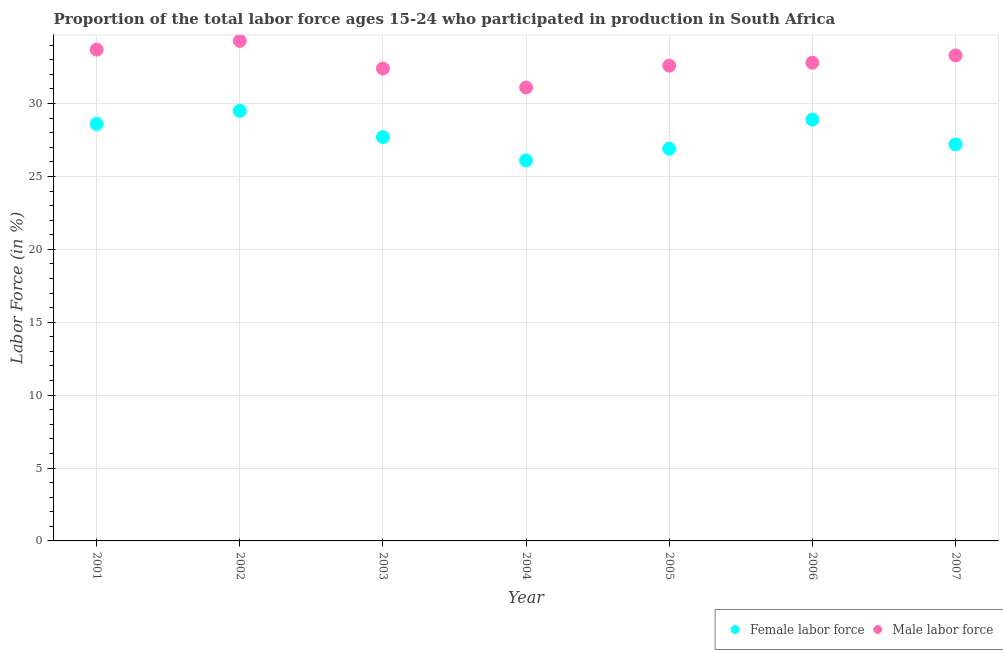How many different coloured dotlines are there?
Give a very brief answer. 2. Is the number of dotlines equal to the number of legend labels?
Offer a terse response. Yes. What is the percentage of male labour force in 2005?
Make the answer very short. 32.6. Across all years, what is the maximum percentage of male labour force?
Keep it short and to the point. 34.3. Across all years, what is the minimum percentage of male labour force?
Your answer should be compact. 31.1. What is the total percentage of male labour force in the graph?
Offer a terse response. 230.2. What is the difference between the percentage of male labour force in 2004 and that in 2006?
Offer a very short reply. -1.7. What is the difference between the percentage of female labor force in 2006 and the percentage of male labour force in 2004?
Offer a very short reply. -2.2. What is the average percentage of male labour force per year?
Your answer should be compact. 32.89. In the year 2001, what is the difference between the percentage of female labor force and percentage of male labour force?
Provide a succinct answer. -5.1. What is the ratio of the percentage of female labor force in 2002 to that in 2006?
Keep it short and to the point. 1.02. What is the difference between the highest and the second highest percentage of female labor force?
Provide a succinct answer. 0.6. What is the difference between the highest and the lowest percentage of male labour force?
Provide a short and direct response. 3.2. In how many years, is the percentage of male labour force greater than the average percentage of male labour force taken over all years?
Ensure brevity in your answer.  3. Is the sum of the percentage of male labour force in 2003 and 2004 greater than the maximum percentage of female labor force across all years?
Make the answer very short. Yes. Does the percentage of female labor force monotonically increase over the years?
Ensure brevity in your answer.  No. Is the percentage of male labour force strictly less than the percentage of female labor force over the years?
Make the answer very short. No. How many dotlines are there?
Make the answer very short. 2. How many years are there in the graph?
Keep it short and to the point. 7. What is the difference between two consecutive major ticks on the Y-axis?
Your answer should be very brief. 5. Does the graph contain grids?
Offer a terse response. Yes. Where does the legend appear in the graph?
Your answer should be compact. Bottom right. What is the title of the graph?
Your answer should be compact. Proportion of the total labor force ages 15-24 who participated in production in South Africa. What is the label or title of the X-axis?
Give a very brief answer. Year. What is the Labor Force (in %) in Female labor force in 2001?
Keep it short and to the point. 28.6. What is the Labor Force (in %) of Male labor force in 2001?
Offer a very short reply. 33.7. What is the Labor Force (in %) in Female labor force in 2002?
Ensure brevity in your answer.  29.5. What is the Labor Force (in %) of Male labor force in 2002?
Ensure brevity in your answer.  34.3. What is the Labor Force (in %) of Female labor force in 2003?
Provide a succinct answer. 27.7. What is the Labor Force (in %) of Male labor force in 2003?
Offer a terse response. 32.4. What is the Labor Force (in %) of Female labor force in 2004?
Your answer should be very brief. 26.1. What is the Labor Force (in %) of Male labor force in 2004?
Your answer should be compact. 31.1. What is the Labor Force (in %) of Female labor force in 2005?
Offer a very short reply. 26.9. What is the Labor Force (in %) in Male labor force in 2005?
Ensure brevity in your answer.  32.6. What is the Labor Force (in %) of Female labor force in 2006?
Offer a very short reply. 28.9. What is the Labor Force (in %) of Male labor force in 2006?
Your answer should be compact. 32.8. What is the Labor Force (in %) of Female labor force in 2007?
Make the answer very short. 27.2. What is the Labor Force (in %) in Male labor force in 2007?
Offer a very short reply. 33.3. Across all years, what is the maximum Labor Force (in %) in Female labor force?
Keep it short and to the point. 29.5. Across all years, what is the maximum Labor Force (in %) in Male labor force?
Ensure brevity in your answer.  34.3. Across all years, what is the minimum Labor Force (in %) in Female labor force?
Give a very brief answer. 26.1. Across all years, what is the minimum Labor Force (in %) of Male labor force?
Provide a succinct answer. 31.1. What is the total Labor Force (in %) in Female labor force in the graph?
Make the answer very short. 194.9. What is the total Labor Force (in %) in Male labor force in the graph?
Offer a terse response. 230.2. What is the difference between the Labor Force (in %) in Female labor force in 2001 and that in 2002?
Your answer should be compact. -0.9. What is the difference between the Labor Force (in %) of Male labor force in 2001 and that in 2002?
Offer a terse response. -0.6. What is the difference between the Labor Force (in %) in Female labor force in 2001 and that in 2003?
Provide a succinct answer. 0.9. What is the difference between the Labor Force (in %) in Male labor force in 2001 and that in 2006?
Your answer should be compact. 0.9. What is the difference between the Labor Force (in %) of Female labor force in 2001 and that in 2007?
Your answer should be very brief. 1.4. What is the difference between the Labor Force (in %) of Male labor force in 2002 and that in 2003?
Your response must be concise. 1.9. What is the difference between the Labor Force (in %) in Female labor force in 2002 and that in 2005?
Ensure brevity in your answer.  2.6. What is the difference between the Labor Force (in %) in Male labor force in 2002 and that in 2005?
Your response must be concise. 1.7. What is the difference between the Labor Force (in %) of Male labor force in 2002 and that in 2006?
Keep it short and to the point. 1.5. What is the difference between the Labor Force (in %) in Female labor force in 2003 and that in 2004?
Offer a terse response. 1.6. What is the difference between the Labor Force (in %) of Male labor force in 2003 and that in 2004?
Offer a terse response. 1.3. What is the difference between the Labor Force (in %) in Female labor force in 2003 and that in 2005?
Provide a short and direct response. 0.8. What is the difference between the Labor Force (in %) in Male labor force in 2003 and that in 2005?
Your response must be concise. -0.2. What is the difference between the Labor Force (in %) of Female labor force in 2004 and that in 2005?
Offer a terse response. -0.8. What is the difference between the Labor Force (in %) of Male labor force in 2004 and that in 2006?
Your response must be concise. -1.7. What is the difference between the Labor Force (in %) in Female labor force in 2004 and that in 2007?
Offer a terse response. -1.1. What is the difference between the Labor Force (in %) in Male labor force in 2004 and that in 2007?
Your answer should be very brief. -2.2. What is the difference between the Labor Force (in %) of Male labor force in 2006 and that in 2007?
Make the answer very short. -0.5. What is the difference between the Labor Force (in %) in Female labor force in 2001 and the Labor Force (in %) in Male labor force in 2002?
Your response must be concise. -5.7. What is the difference between the Labor Force (in %) in Female labor force in 2001 and the Labor Force (in %) in Male labor force in 2003?
Ensure brevity in your answer.  -3.8. What is the difference between the Labor Force (in %) in Female labor force in 2001 and the Labor Force (in %) in Male labor force in 2007?
Ensure brevity in your answer.  -4.7. What is the difference between the Labor Force (in %) of Female labor force in 2002 and the Labor Force (in %) of Male labor force in 2004?
Your response must be concise. -1.6. What is the difference between the Labor Force (in %) of Female labor force in 2002 and the Labor Force (in %) of Male labor force in 2005?
Your answer should be very brief. -3.1. What is the difference between the Labor Force (in %) in Female labor force in 2002 and the Labor Force (in %) in Male labor force in 2007?
Your answer should be very brief. -3.8. What is the difference between the Labor Force (in %) in Female labor force in 2003 and the Labor Force (in %) in Male labor force in 2005?
Keep it short and to the point. -4.9. What is the difference between the Labor Force (in %) of Female labor force in 2003 and the Labor Force (in %) of Male labor force in 2007?
Your response must be concise. -5.6. What is the difference between the Labor Force (in %) of Female labor force in 2005 and the Labor Force (in %) of Male labor force in 2007?
Give a very brief answer. -6.4. What is the difference between the Labor Force (in %) in Female labor force in 2006 and the Labor Force (in %) in Male labor force in 2007?
Your answer should be compact. -4.4. What is the average Labor Force (in %) of Female labor force per year?
Your answer should be compact. 27.84. What is the average Labor Force (in %) of Male labor force per year?
Keep it short and to the point. 32.89. In the year 2002, what is the difference between the Labor Force (in %) in Female labor force and Labor Force (in %) in Male labor force?
Keep it short and to the point. -4.8. In the year 2003, what is the difference between the Labor Force (in %) in Female labor force and Labor Force (in %) in Male labor force?
Keep it short and to the point. -4.7. In the year 2005, what is the difference between the Labor Force (in %) of Female labor force and Labor Force (in %) of Male labor force?
Your response must be concise. -5.7. What is the ratio of the Labor Force (in %) in Female labor force in 2001 to that in 2002?
Offer a terse response. 0.97. What is the ratio of the Labor Force (in %) in Male labor force in 2001 to that in 2002?
Your answer should be compact. 0.98. What is the ratio of the Labor Force (in %) in Female labor force in 2001 to that in 2003?
Provide a succinct answer. 1.03. What is the ratio of the Labor Force (in %) in Male labor force in 2001 to that in 2003?
Provide a short and direct response. 1.04. What is the ratio of the Labor Force (in %) in Female labor force in 2001 to that in 2004?
Make the answer very short. 1.1. What is the ratio of the Labor Force (in %) of Male labor force in 2001 to that in 2004?
Provide a short and direct response. 1.08. What is the ratio of the Labor Force (in %) in Female labor force in 2001 to that in 2005?
Provide a succinct answer. 1.06. What is the ratio of the Labor Force (in %) in Male labor force in 2001 to that in 2005?
Offer a very short reply. 1.03. What is the ratio of the Labor Force (in %) of Male labor force in 2001 to that in 2006?
Provide a short and direct response. 1.03. What is the ratio of the Labor Force (in %) of Female labor force in 2001 to that in 2007?
Ensure brevity in your answer.  1.05. What is the ratio of the Labor Force (in %) in Female labor force in 2002 to that in 2003?
Make the answer very short. 1.06. What is the ratio of the Labor Force (in %) of Male labor force in 2002 to that in 2003?
Ensure brevity in your answer.  1.06. What is the ratio of the Labor Force (in %) in Female labor force in 2002 to that in 2004?
Keep it short and to the point. 1.13. What is the ratio of the Labor Force (in %) of Male labor force in 2002 to that in 2004?
Give a very brief answer. 1.1. What is the ratio of the Labor Force (in %) of Female labor force in 2002 to that in 2005?
Provide a short and direct response. 1.1. What is the ratio of the Labor Force (in %) of Male labor force in 2002 to that in 2005?
Keep it short and to the point. 1.05. What is the ratio of the Labor Force (in %) in Female labor force in 2002 to that in 2006?
Provide a succinct answer. 1.02. What is the ratio of the Labor Force (in %) of Male labor force in 2002 to that in 2006?
Offer a very short reply. 1.05. What is the ratio of the Labor Force (in %) in Female labor force in 2002 to that in 2007?
Give a very brief answer. 1.08. What is the ratio of the Labor Force (in %) of Female labor force in 2003 to that in 2004?
Provide a short and direct response. 1.06. What is the ratio of the Labor Force (in %) of Male labor force in 2003 to that in 2004?
Give a very brief answer. 1.04. What is the ratio of the Labor Force (in %) in Female labor force in 2003 to that in 2005?
Your response must be concise. 1.03. What is the ratio of the Labor Force (in %) of Male labor force in 2003 to that in 2005?
Your answer should be very brief. 0.99. What is the ratio of the Labor Force (in %) in Female labor force in 2003 to that in 2006?
Offer a very short reply. 0.96. What is the ratio of the Labor Force (in %) of Male labor force in 2003 to that in 2006?
Your response must be concise. 0.99. What is the ratio of the Labor Force (in %) in Female labor force in 2003 to that in 2007?
Keep it short and to the point. 1.02. What is the ratio of the Labor Force (in %) in Female labor force in 2004 to that in 2005?
Offer a terse response. 0.97. What is the ratio of the Labor Force (in %) of Male labor force in 2004 to that in 2005?
Make the answer very short. 0.95. What is the ratio of the Labor Force (in %) in Female labor force in 2004 to that in 2006?
Ensure brevity in your answer.  0.9. What is the ratio of the Labor Force (in %) in Male labor force in 2004 to that in 2006?
Your answer should be very brief. 0.95. What is the ratio of the Labor Force (in %) in Female labor force in 2004 to that in 2007?
Your answer should be compact. 0.96. What is the ratio of the Labor Force (in %) of Male labor force in 2004 to that in 2007?
Provide a short and direct response. 0.93. What is the ratio of the Labor Force (in %) in Female labor force in 2005 to that in 2006?
Offer a terse response. 0.93. What is the ratio of the Labor Force (in %) of Female labor force in 2005 to that in 2007?
Offer a terse response. 0.99. What is the difference between the highest and the second highest Labor Force (in %) in Female labor force?
Ensure brevity in your answer.  0.6. 